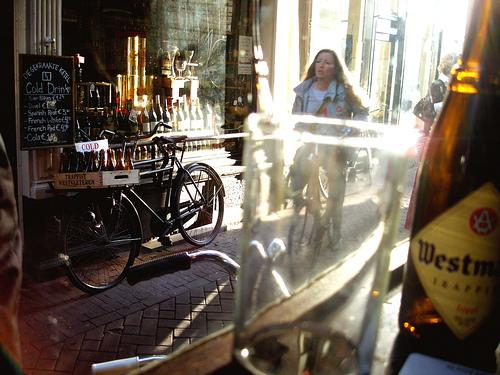This store likely sells what?

Choices:
A) books
B) beer
C) caviar
D) marbles beer 